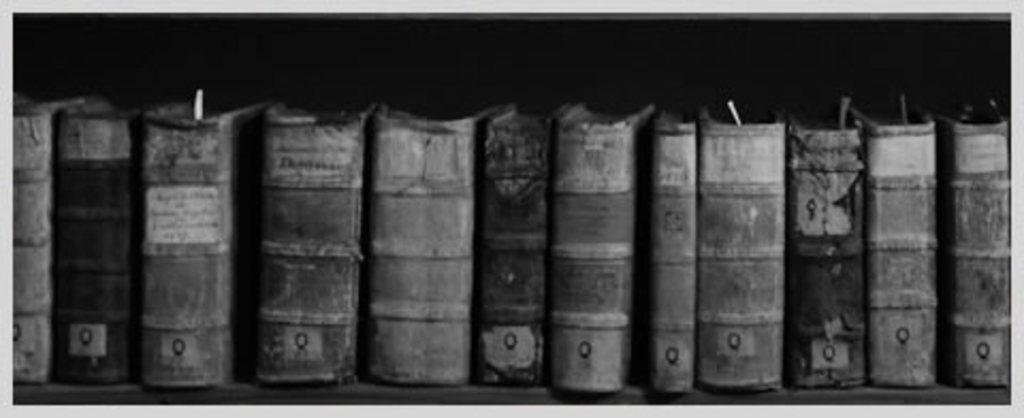Please provide a concise description of this image. This is a black and white image. In this image we can see books arranged in the rows. 